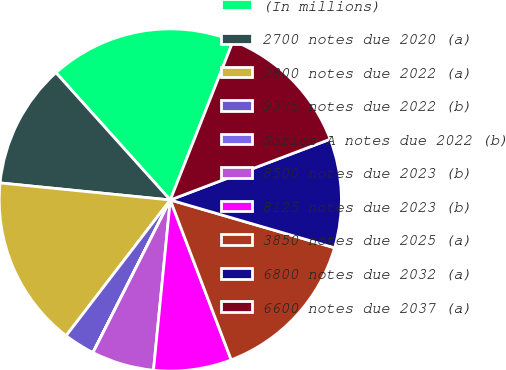Convert chart to OTSL. <chart><loc_0><loc_0><loc_500><loc_500><pie_chart><fcel>(In millions)<fcel>2700 notes due 2020 (a)<fcel>2800 notes due 2022 (a)<fcel>9375 notes due 2022 (b)<fcel>Series A notes due 2022 (b)<fcel>8500 notes due 2023 (b)<fcel>8125 notes due 2023 (b)<fcel>3850 notes due 2025 (a)<fcel>6800 notes due 2032 (a)<fcel>6600 notes due 2037 (a)<nl><fcel>17.64%<fcel>11.76%<fcel>16.17%<fcel>2.95%<fcel>0.01%<fcel>5.89%<fcel>7.36%<fcel>14.7%<fcel>10.29%<fcel>13.23%<nl></chart> 